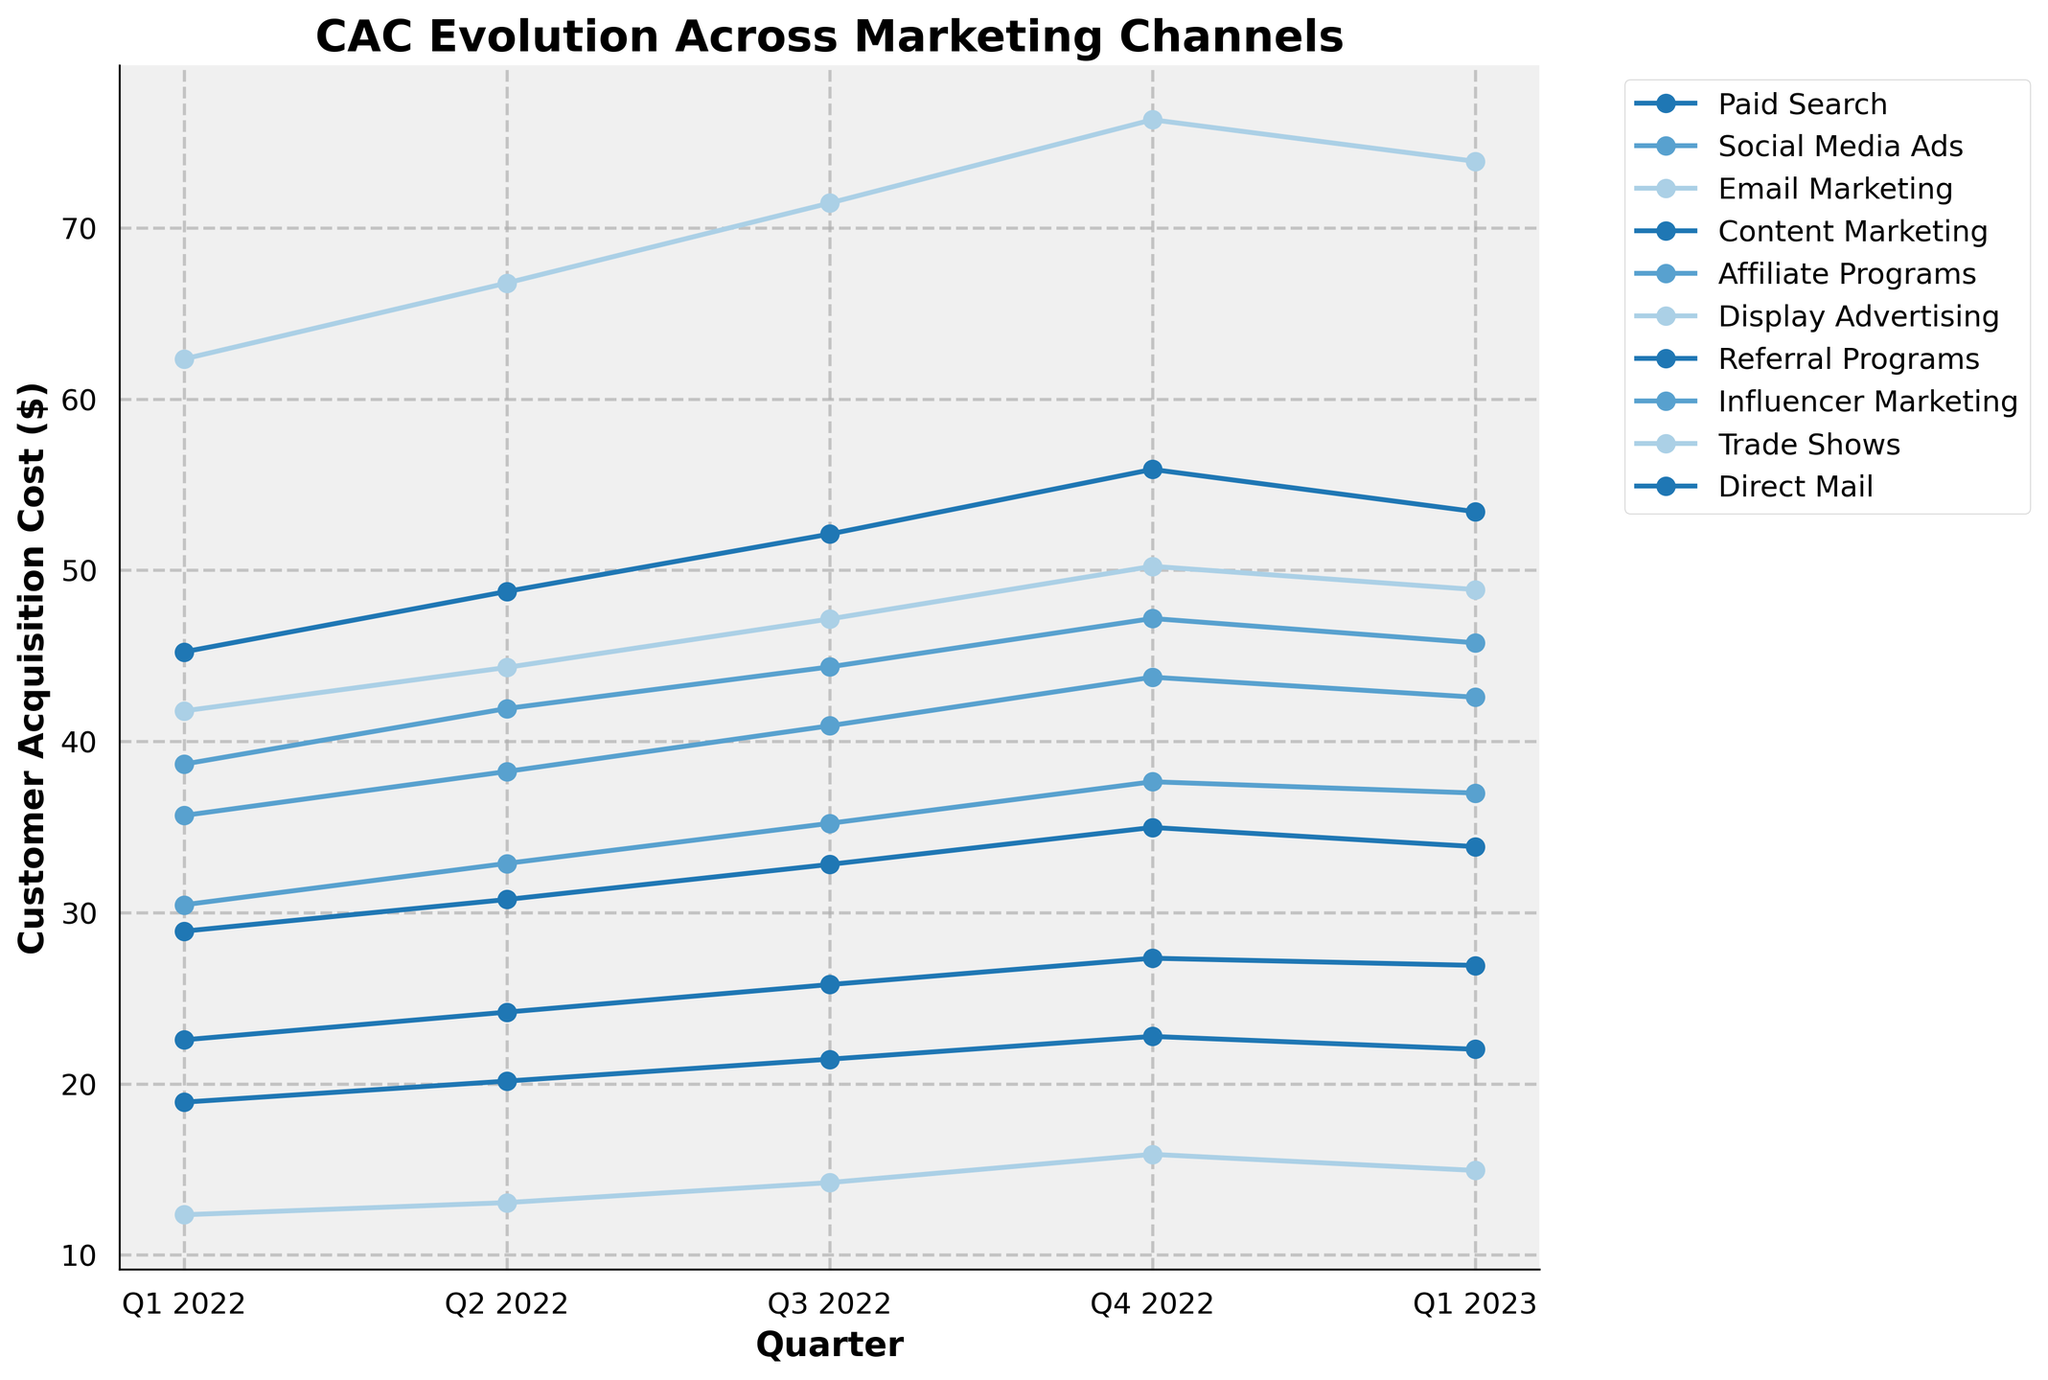What's the trend in CAC for Social Media Ads from Q1 2022 to Q4 2022? To identify the trend, observe how the Customer Acquisition Cost (CAC) values for Social Media Ads change across the quarters from Q1 2022 to Q4 2022. Each value increases from one quarter to the next (38.67, 41.92, 44.35, 47.18). This indicates a rising trend.
Answer: Rising trend Which channel shows the highest CAC in Q1 2023? To find the highest CAC in Q1 2023, compare the values of all channels for Q1 2023. Trade Shows has the highest value at 73.89.
Answer: Trade Shows How does the CAC for Email Marketing in Q1 2022 compare to Q1 2023? Compare the two CAC values for Email Marketing: Q1 2022 is 12.34, and Q1 2023 is 14.93. Thus, the CAC has increased from Q1 2022 to Q1 2023.
Answer: Increased Which marketing channel had the lowest CAC throughout 2022? Add the CAC values for each channel from Q1 to Q4 2022 and identify the lowest sum. Email Marketing has the lowest values (12.34 + 13.05 + 14.22 + 15.87) = 55.48.
Answer: Email Marketing What is the average CAC for Paid Search in 2022? Add the Paid Search values for 2022: (45.23 + 48.76 + 52.11 + 55.89) = 201.99. Then divide by 4: 201.99/4 = 50.50.
Answer: 50.50 Compare the CAC of Trade Shows and Direct Mail in Q4 2022. Which is higher? Check the CAC values for Trade Shows and Direct Mail in Q4 2022. Trade Shows is 76.32, and Direct Mail is 34.97. Trade Shows is higher.
Answer: Trade Shows What is the overall trend for Display Advertising from Q1 2022 to Q1 2023? Examine the CAC values for Display Advertising: 41.78, 44.32, 47.15, 50.23, 48.87. The values increase until Q4 2022 and then slightly decrease in Q1 2023. This overall shows an upward trend with a slight drop at the end.
Answer: Upward trend with slight drop Which two channels had the closest CAC values in Q2 2022? Compare the CAC values for Q2 2022 across all channels to identify the closest pair. Referral Programs (20.15) and Content Marketing (24.18) have a difference of 4.03, which is among the smallest differences.
Answer: Referral Programs and Content Marketing Calculate the percentage increase in CAC for Affiliate Programs from Q1 2022 to Q4 2022. Q1 2022 value is 30.45 and Q4 2022 is 37.64. Percentage increase = ((37.64 - 30.45) / 30.45) * 100 = 23.59%.
Answer: 23.59% What is the median CAC value for Influencer Marketing in 2022? Arrange Influencer Marketing values for 2022: 35.67, 38.24, 40.91, 43.75. Median is the average of the two middle values: (38.24 + 40.91) / 2 = 39.58.
Answer: 39.58 